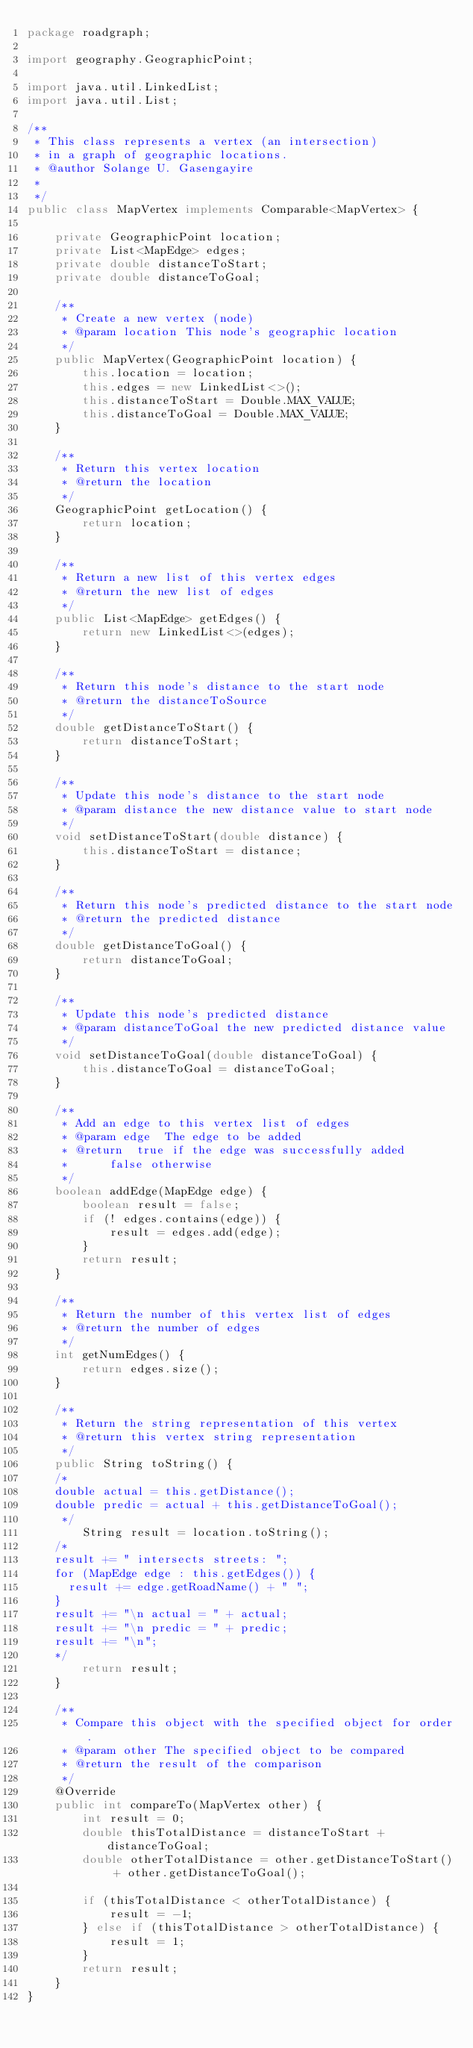Convert code to text. <code><loc_0><loc_0><loc_500><loc_500><_Java_>package roadgraph;

import geography.GeographicPoint;

import java.util.LinkedList;
import java.util.List;

/**
 * This class represents a vertex (an intersection)
 * in a graph of geographic locations.
 * @author Solange U. Gasengayire
 *
 */
public class MapVertex implements Comparable<MapVertex> {

    private GeographicPoint location;
    private List<MapEdge> edges;
    private double distanceToStart;
    private double distanceToGoal;

    /**
     * Create a new vertex (node)
     * @param location This node's geographic location
     */
    public MapVertex(GeographicPoint location) {
        this.location = location;
        this.edges = new LinkedList<>();
        this.distanceToStart = Double.MAX_VALUE;
        this.distanceToGoal = Double.MAX_VALUE;
    }

    /**
     * Return this vertex location
     * @return the location
     */
    GeographicPoint getLocation() {
        return location;
    }

    /**
     * Return a new list of this vertex edges
     * @return the new list of edges
     */
    public List<MapEdge> getEdges() {
        return new LinkedList<>(edges);
    }

    /**
     * Return this node's distance to the start node
     * @return the distanceToSource
     */
    double getDistanceToStart() {
        return distanceToStart;
    }

    /**
     * Update this node's distance to the start node
     * @param distance the new distance value to start node
     */
    void setDistanceToStart(double distance) {
        this.distanceToStart = distance;
    }

    /**
     * Return this node's predicted distance to the start node
     * @return the predicted distance
     */
    double getDistanceToGoal() {
        return distanceToGoal;
    }

    /**
     * Update this node's predicted distance
     * @param distanceToGoal the new predicted distance value
     */
    void setDistanceToGoal(double distanceToGoal) {
        this.distanceToGoal = distanceToGoal;
    }

    /**
     * Add an edge to this vertex list of edges
     * @param edge	The edge to be added
     * @return	true if the edge was successfully added
     * 			false otherwise
     */
    boolean addEdge(MapEdge edge) {
        boolean result = false;
        if (! edges.contains(edge)) {
            result = edges.add(edge);
        }
        return result;
    }

    /**
     * Return the number of this vertex list of edges
     * @return the number of edges
     */
    int getNumEdges() {
        return edges.size();
    }

    /**
     * Return the string representation of this vertex
     * @return this vertex string representation
     */
    public String toString() {
		/*
		double actual = this.getDistance();
		double predic = actual + this.getDistanceToGoal();
		 */
        String result = location.toString();
		/*
		result += " intersects streets: ";
		for (MapEdge edge : this.getEdges()) {
			result += edge.getRoadName() + " ";
		}
		result += "\n actual = " + actual;
		result += "\n predic = " + predic;
		result += "\n";
		*/
        return result;
    }

    /**
     * Compare this object with the specified object for order.
     * @param other The specified object to be compared
     * @return the result of the comparison
     */
    @Override
    public int compareTo(MapVertex other) {
        int result = 0;
        double thisTotalDistance = distanceToStart + distanceToGoal;
        double otherTotalDistance = other.getDistanceToStart() + other.getDistanceToGoal();

        if (thisTotalDistance < otherTotalDistance) {
            result = -1;
        } else if (thisTotalDistance > otherTotalDistance) {
            result = 1;
        }
        return result;
    }
}
</code> 